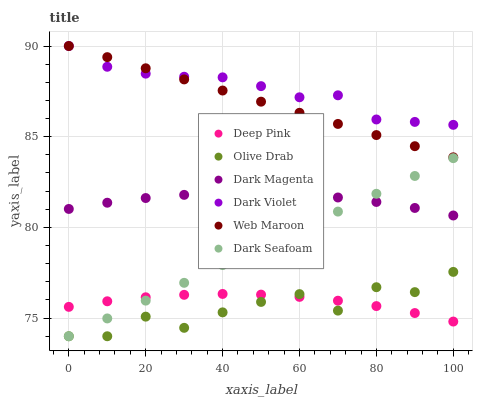Does Olive Drab have the minimum area under the curve?
Answer yes or no. Yes. Does Dark Violet have the maximum area under the curve?
Answer yes or no. Yes. Does Dark Magenta have the minimum area under the curve?
Answer yes or no. No. Does Dark Magenta have the maximum area under the curve?
Answer yes or no. No. Is Dark Seafoam the smoothest?
Answer yes or no. Yes. Is Olive Drab the roughest?
Answer yes or no. Yes. Is Dark Magenta the smoothest?
Answer yes or no. No. Is Dark Magenta the roughest?
Answer yes or no. No. Does Dark Seafoam have the lowest value?
Answer yes or no. Yes. Does Dark Magenta have the lowest value?
Answer yes or no. No. Does Dark Violet have the highest value?
Answer yes or no. Yes. Does Dark Magenta have the highest value?
Answer yes or no. No. Is Deep Pink less than Dark Magenta?
Answer yes or no. Yes. Is Web Maroon greater than Dark Seafoam?
Answer yes or no. Yes. Does Dark Seafoam intersect Dark Magenta?
Answer yes or no. Yes. Is Dark Seafoam less than Dark Magenta?
Answer yes or no. No. Is Dark Seafoam greater than Dark Magenta?
Answer yes or no. No. Does Deep Pink intersect Dark Magenta?
Answer yes or no. No. 